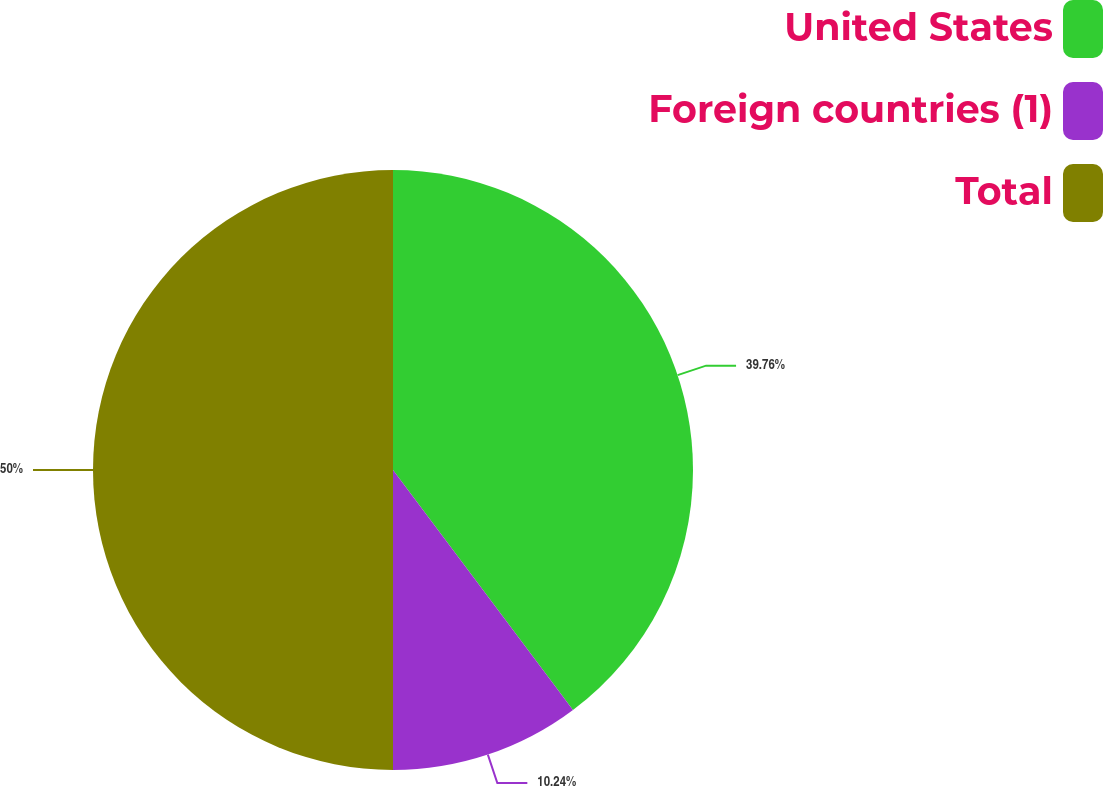<chart> <loc_0><loc_0><loc_500><loc_500><pie_chart><fcel>United States<fcel>Foreign countries (1)<fcel>Total<nl><fcel>39.76%<fcel>10.24%<fcel>50.0%<nl></chart> 